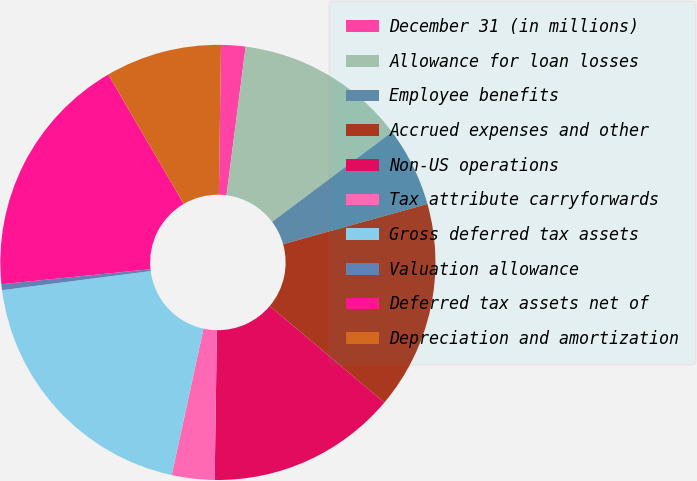<chart> <loc_0><loc_0><loc_500><loc_500><pie_chart><fcel>December 31 (in millions)<fcel>Allowance for loan losses<fcel>Employee benefits<fcel>Accrued expenses and other<fcel>Non-US operations<fcel>Tax attribute carryforwards<fcel>Gross deferred tax assets<fcel>Valuation allowance<fcel>Deferred tax assets net of<fcel>Depreciation and amortization<nl><fcel>1.81%<fcel>12.73%<fcel>5.9%<fcel>15.46%<fcel>14.1%<fcel>3.17%<fcel>19.56%<fcel>0.44%<fcel>18.19%<fcel>8.63%<nl></chart> 